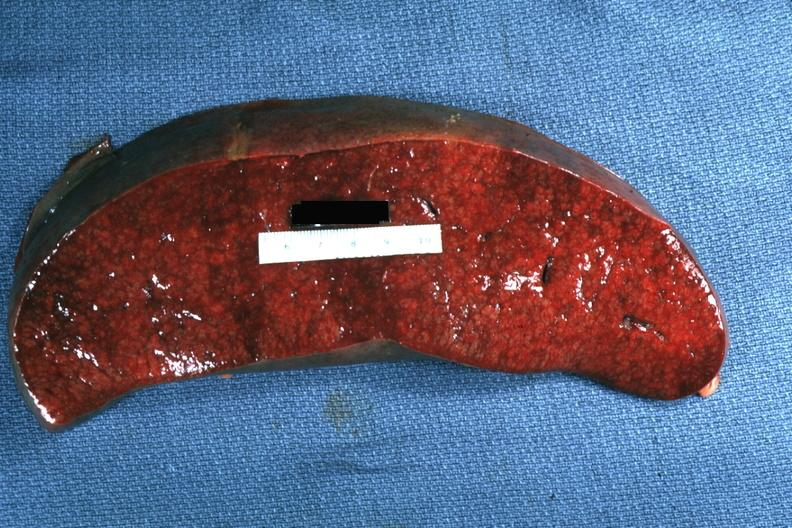s vasculature present?
Answer the question using a single word or phrase. No 